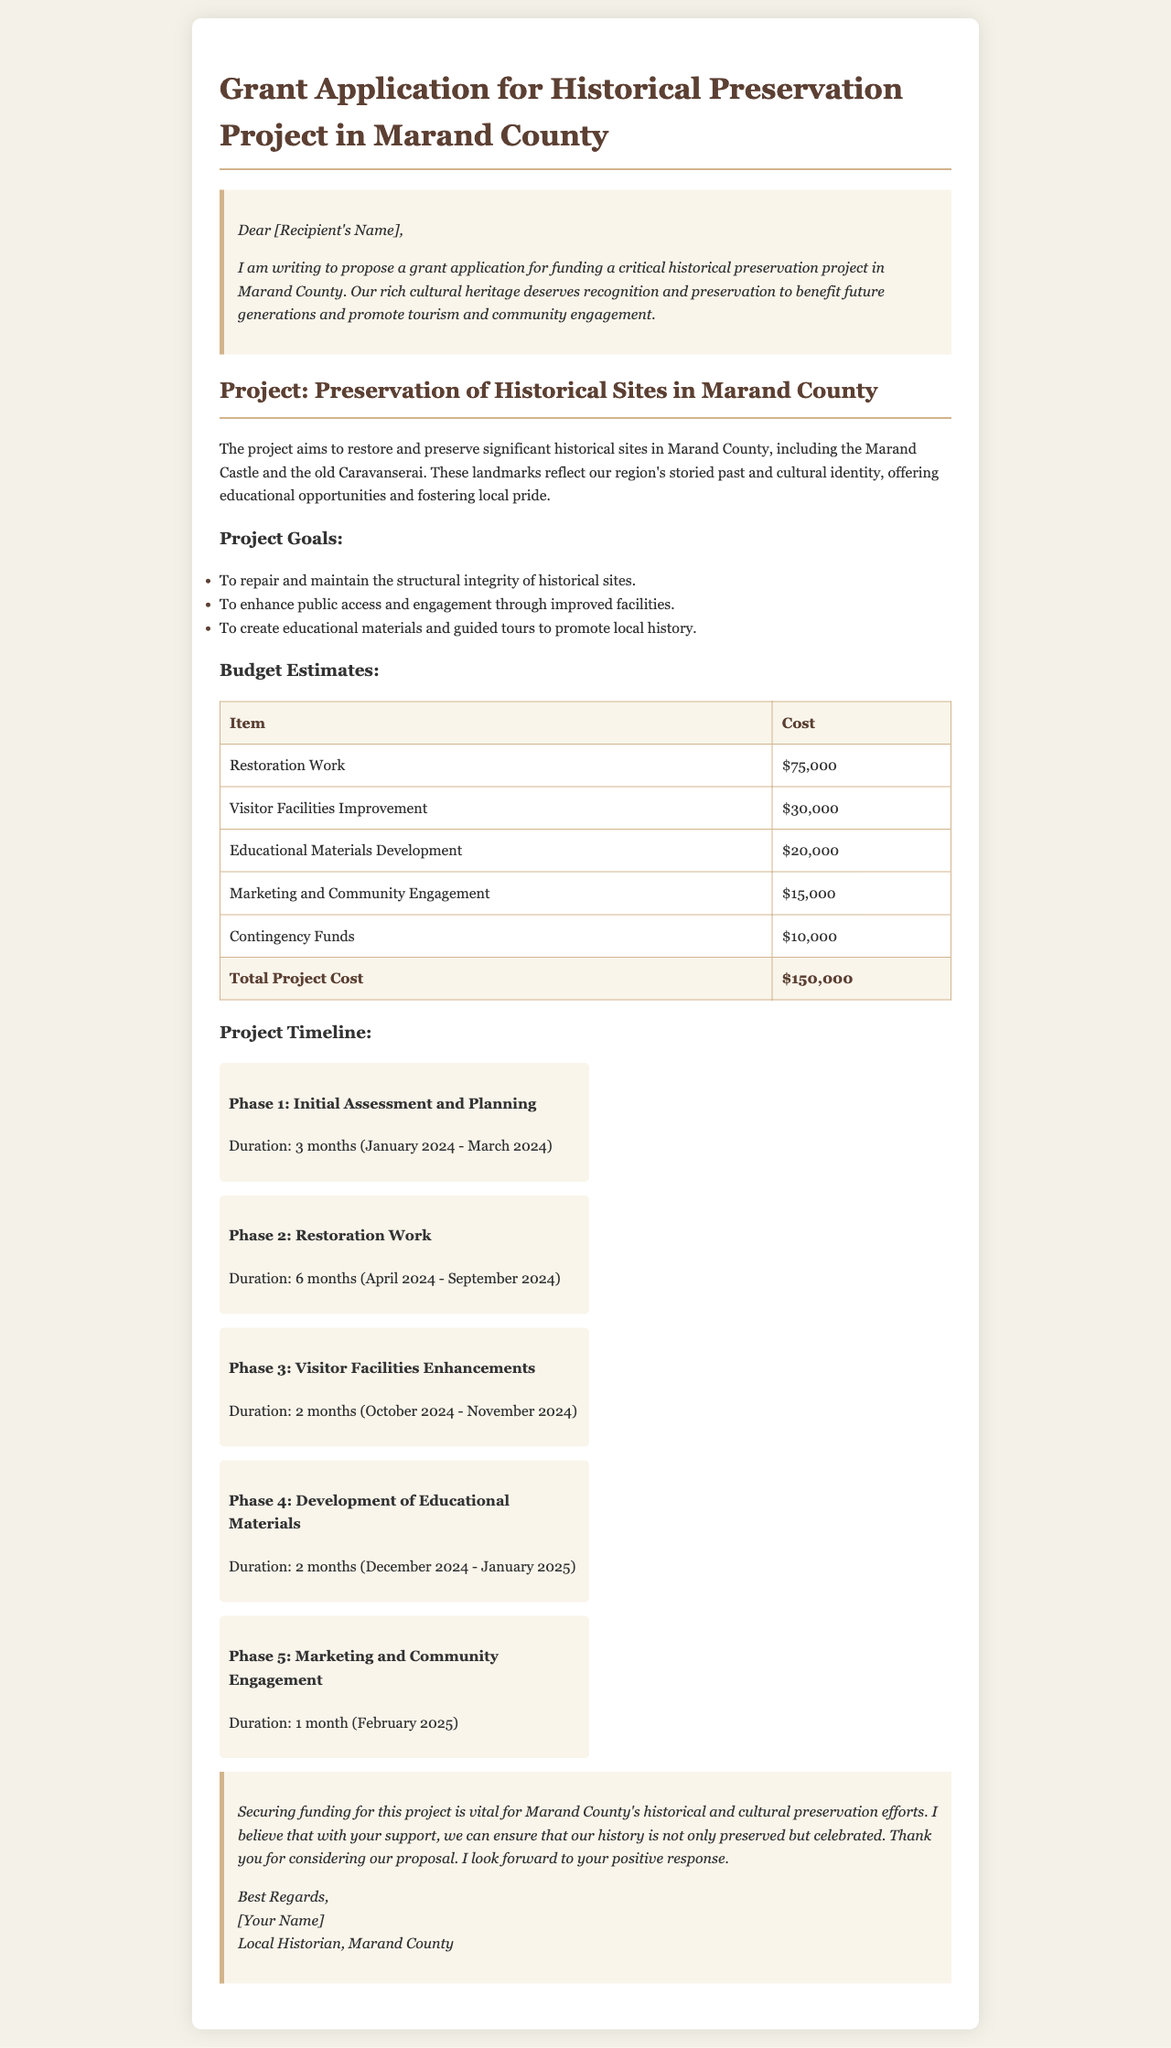what is the total project cost? The total project cost is mentioned in the budget estimates section of the document, which is the sum of all costs listed.
Answer: $150,000 what are some of the historical sites mentioned in the project? The historical sites being preserved are listed in the project description, specifically the Marand Castle and the old Caravanserai.
Answer: Marand Castle and the old Caravanserai how long will the restoration work take? The duration for the restoration work is specified in the project timeline, showing the time frame of the phase dedicated to this work.
Answer: 6 months what is the budget for visitor facilities improvement? The budget estimate for visitor facilities improvement is detailed in the budget table within the document.
Answer: $30,000 which phase of the project is focused on marketing? The project timeline outlines several phases, with the last phase dedicated to marketing and community engagement.
Answer: Phase 5 what are the start and end dates for Phase 1? The document provides specific months for the duration of each phase, allowing us to identify the start and end dates for Phase 1.
Answer: January 2024 - March 2024 what is the main purpose of the grant application? The document states the main goal of the grant application in the introduction and project section.
Answer: To fund a historical preservation project how many total phases are outlined in the project timeline? The project timeline section includes a clear count of phases listed from 1 to 5.
Answer: 5 phases what is the allocated cost for developing educational materials? The budget estimates specifically indicate the cost allocated for this particular item in the budget table.
Answer: $20,000 